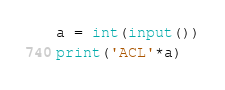Convert code to text. <code><loc_0><loc_0><loc_500><loc_500><_Python_>a = int(input())
print('ACL'*a)</code> 